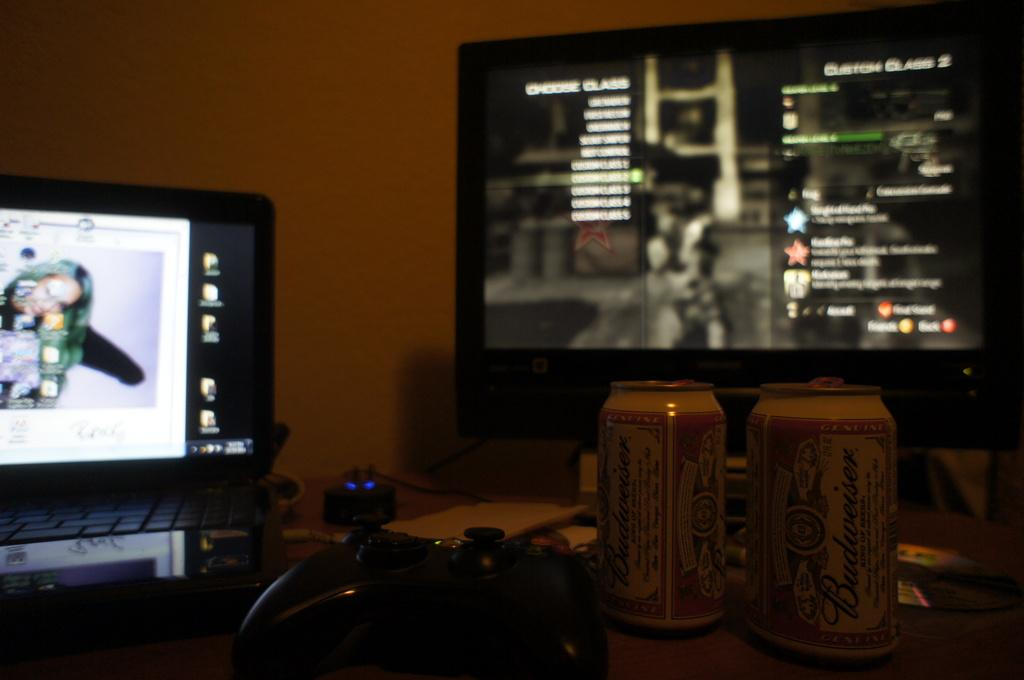<image>
Write a terse but informative summary of the picture. A video game is shown at a selection screen displaying Custom Class 2 